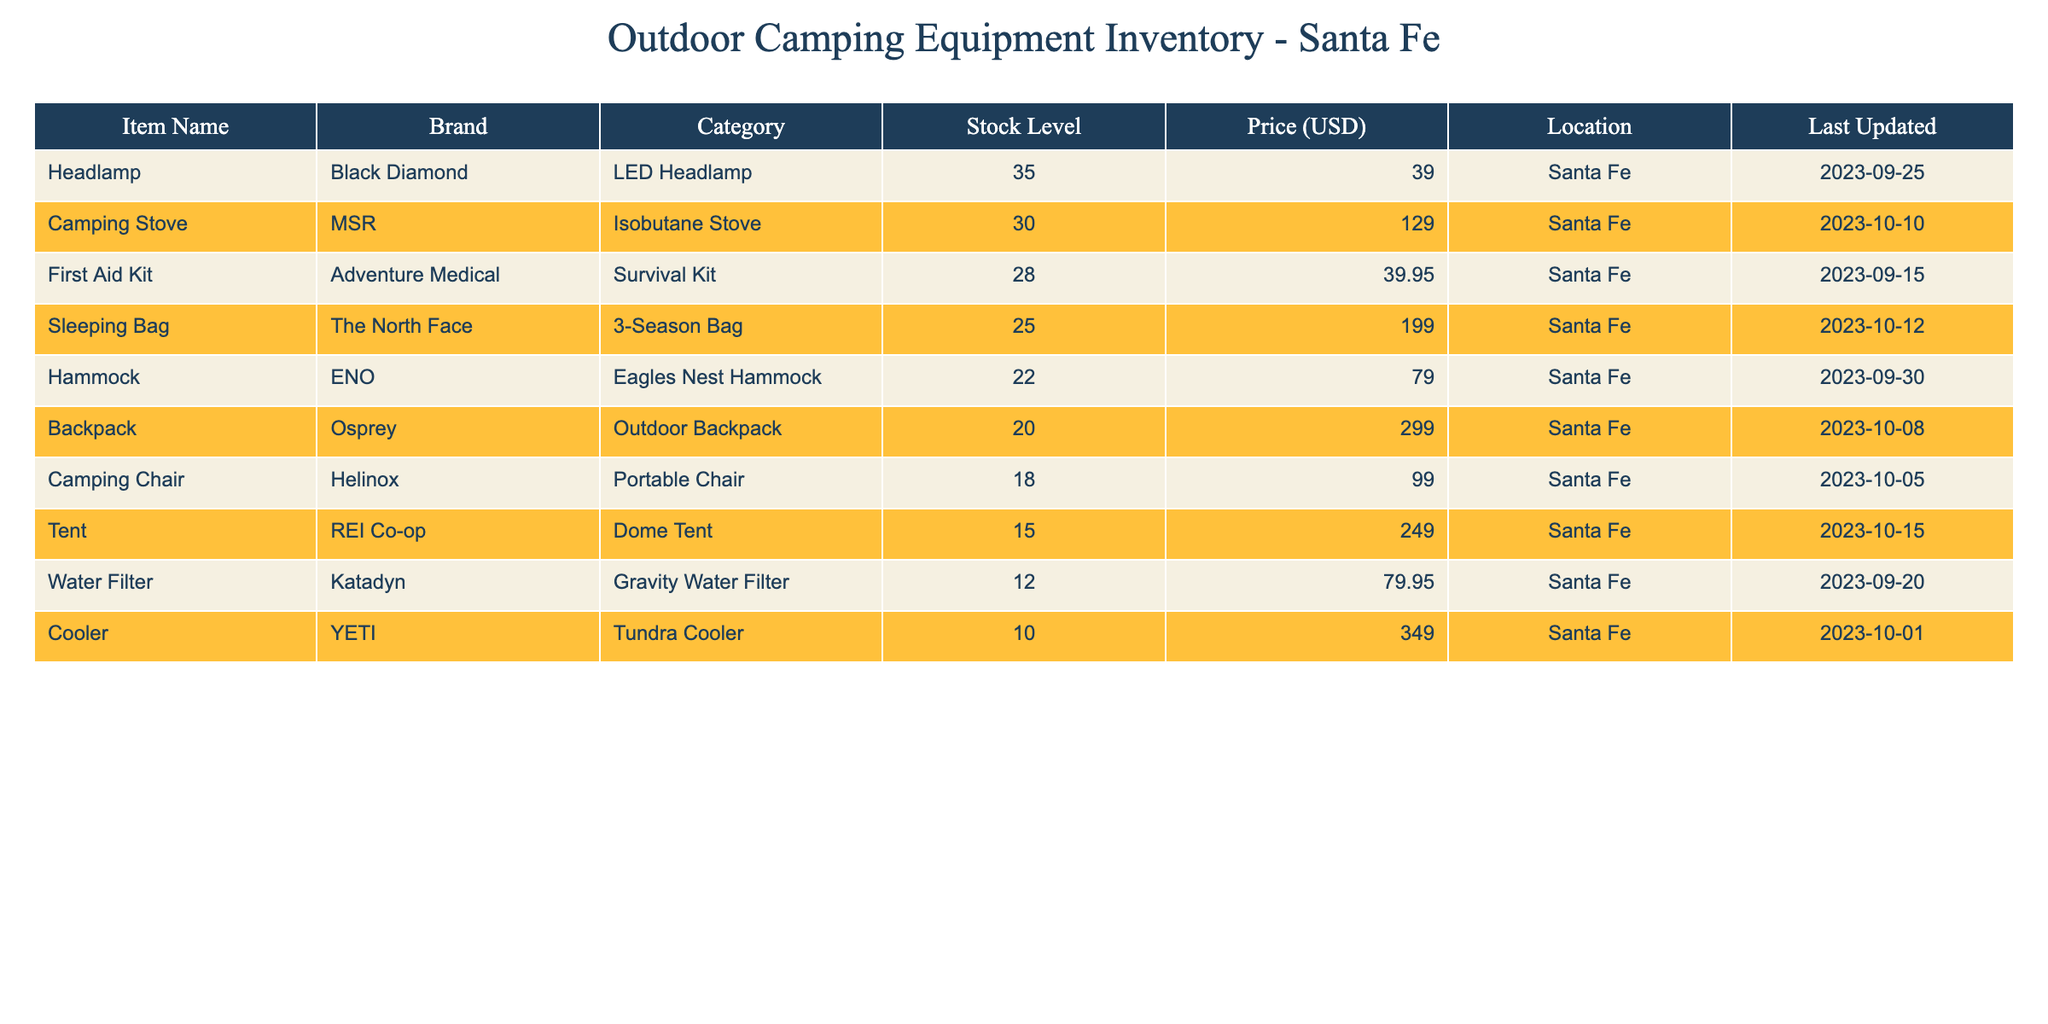What is the stock level for the Camping Stove? The stock level for the Camping Stove is listed directly in the table under the "Stock Level" column. It shows that there are 30 units available.
Answer: 30 Which item has the highest stock level? By checking the "Stock Level" column, the item with the highest stock level is the Sleeping Bag with 25 units.
Answer: Sleeping Bag What is the total price of all items in stock? To calculate, we multiply each item's stock level by its price and sum the totals: (15 * 249) + (25 * 199) + (30 * 129) + (20 * 299) + (18 * 99) + (10 * 349) + (22 * 79) + (35 * 39) + (12 * 79.95) + (28 * 39.95) = 3735 + 4975 + 3870 + 5980 + 1782 + 3490 + 1738 + 1365 + 959.40 + 1118.60 = 22,563.00.
Answer: 22563.00 Does the Camping Chair have a lower stock level than the Cooler? By comparing the "Stock Level" for both items, the Camping Chair has 18 units and the Cooler has 10 units. Since 18 is greater than 10, the Camping Chair does not have a lower stock level; it has more.
Answer: No What is the average stock level across all items? To find the average, we sum all stock levels: 15 + 25 + 30 + 20 + 18 + 10 + 22 + 35 + 12 + 28 =  25. The total of 25 is then divided by the number of items (10), resulting in an average stock level of 25/10 = 25.
Answer: 25 